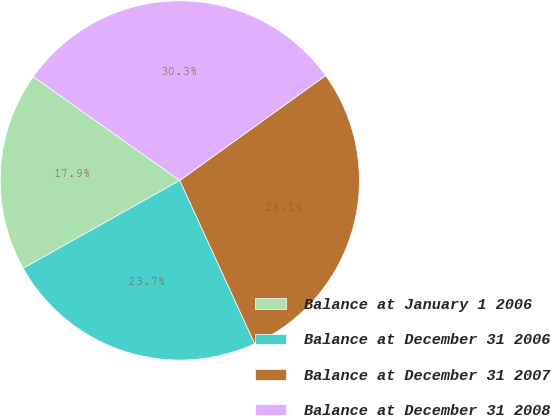<chart> <loc_0><loc_0><loc_500><loc_500><pie_chart><fcel>Balance at January 1 2006<fcel>Balance at December 31 2006<fcel>Balance at December 31 2007<fcel>Balance at December 31 2008<nl><fcel>17.94%<fcel>23.71%<fcel>28.08%<fcel>30.27%<nl></chart> 